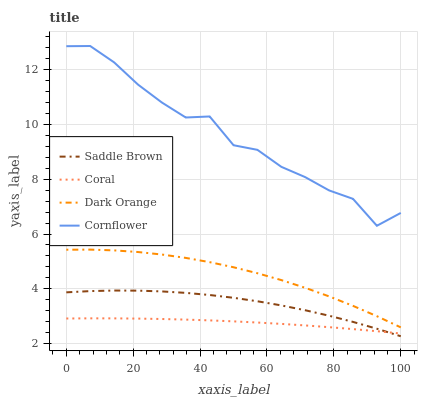Does Coral have the minimum area under the curve?
Answer yes or no. Yes. Does Cornflower have the maximum area under the curve?
Answer yes or no. Yes. Does Saddle Brown have the minimum area under the curve?
Answer yes or no. No. Does Saddle Brown have the maximum area under the curve?
Answer yes or no. No. Is Coral the smoothest?
Answer yes or no. Yes. Is Cornflower the roughest?
Answer yes or no. Yes. Is Saddle Brown the smoothest?
Answer yes or no. No. Is Saddle Brown the roughest?
Answer yes or no. No. Does Saddle Brown have the lowest value?
Answer yes or no. Yes. Does Coral have the lowest value?
Answer yes or no. No. Does Cornflower have the highest value?
Answer yes or no. Yes. Does Saddle Brown have the highest value?
Answer yes or no. No. Is Saddle Brown less than Cornflower?
Answer yes or no. Yes. Is Cornflower greater than Saddle Brown?
Answer yes or no. Yes. Does Coral intersect Saddle Brown?
Answer yes or no. Yes. Is Coral less than Saddle Brown?
Answer yes or no. No. Is Coral greater than Saddle Brown?
Answer yes or no. No. Does Saddle Brown intersect Cornflower?
Answer yes or no. No. 